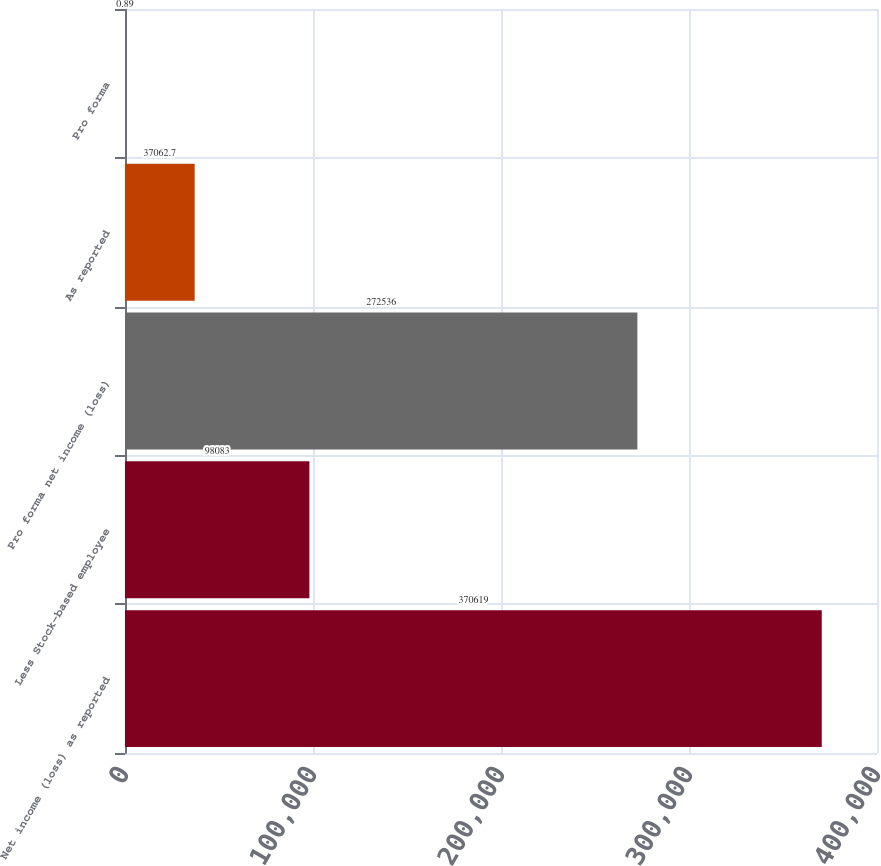Convert chart. <chart><loc_0><loc_0><loc_500><loc_500><bar_chart><fcel>Net income (loss) as reported<fcel>Less Stock-based employee<fcel>Pro forma net income (loss)<fcel>As reported<fcel>Pro forma<nl><fcel>370619<fcel>98083<fcel>272536<fcel>37062.7<fcel>0.89<nl></chart> 